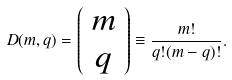<formula> <loc_0><loc_0><loc_500><loc_500>D ( m , q ) = \left ( \begin{array} { c } m \\ q \end{array} \right ) \equiv \frac { m ! } { q ! ( m - q ) ! } .</formula> 